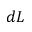Convert formula to latex. <formula><loc_0><loc_0><loc_500><loc_500>d L</formula> 